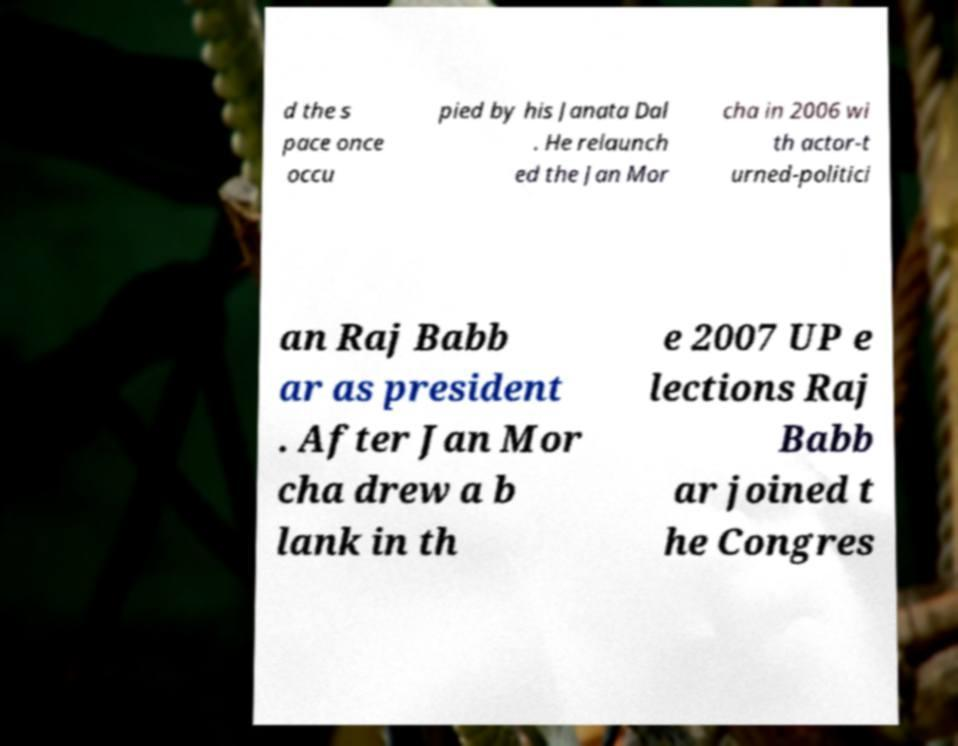Could you extract and type out the text from this image? d the s pace once occu pied by his Janata Dal . He relaunch ed the Jan Mor cha in 2006 wi th actor-t urned-politici an Raj Babb ar as president . After Jan Mor cha drew a b lank in th e 2007 UP e lections Raj Babb ar joined t he Congres 